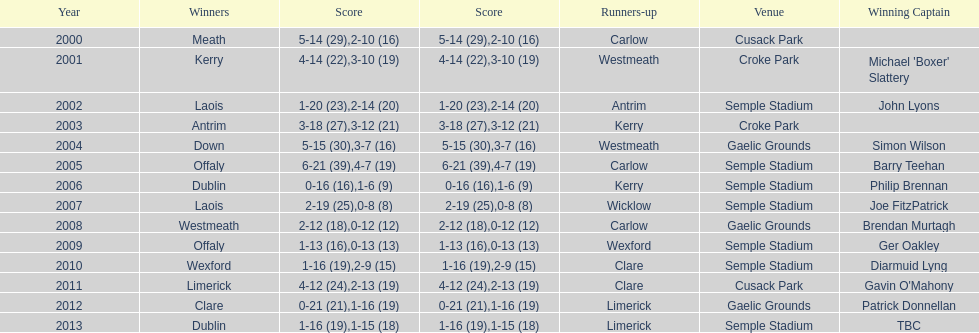What is the overall sum of instances the event occurred at the semple stadium site? 7. 